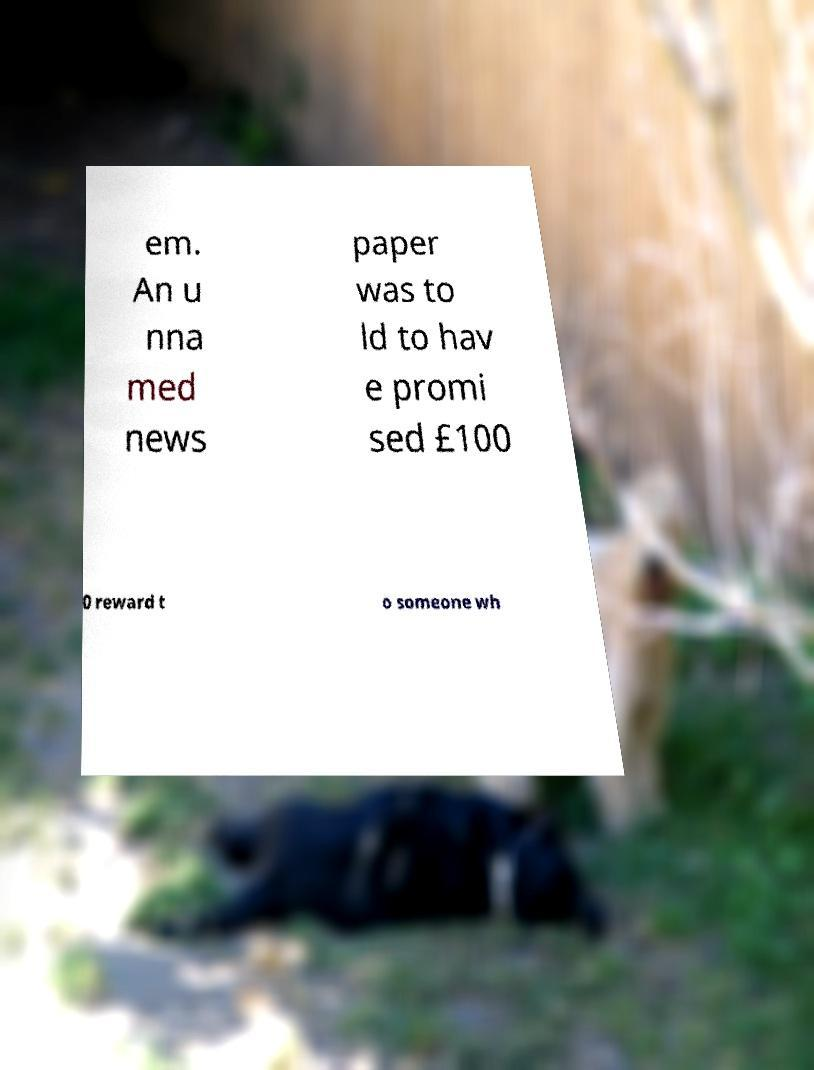Could you assist in decoding the text presented in this image and type it out clearly? em. An u nna med news paper was to ld to hav e promi sed £100 0 reward t o someone wh 